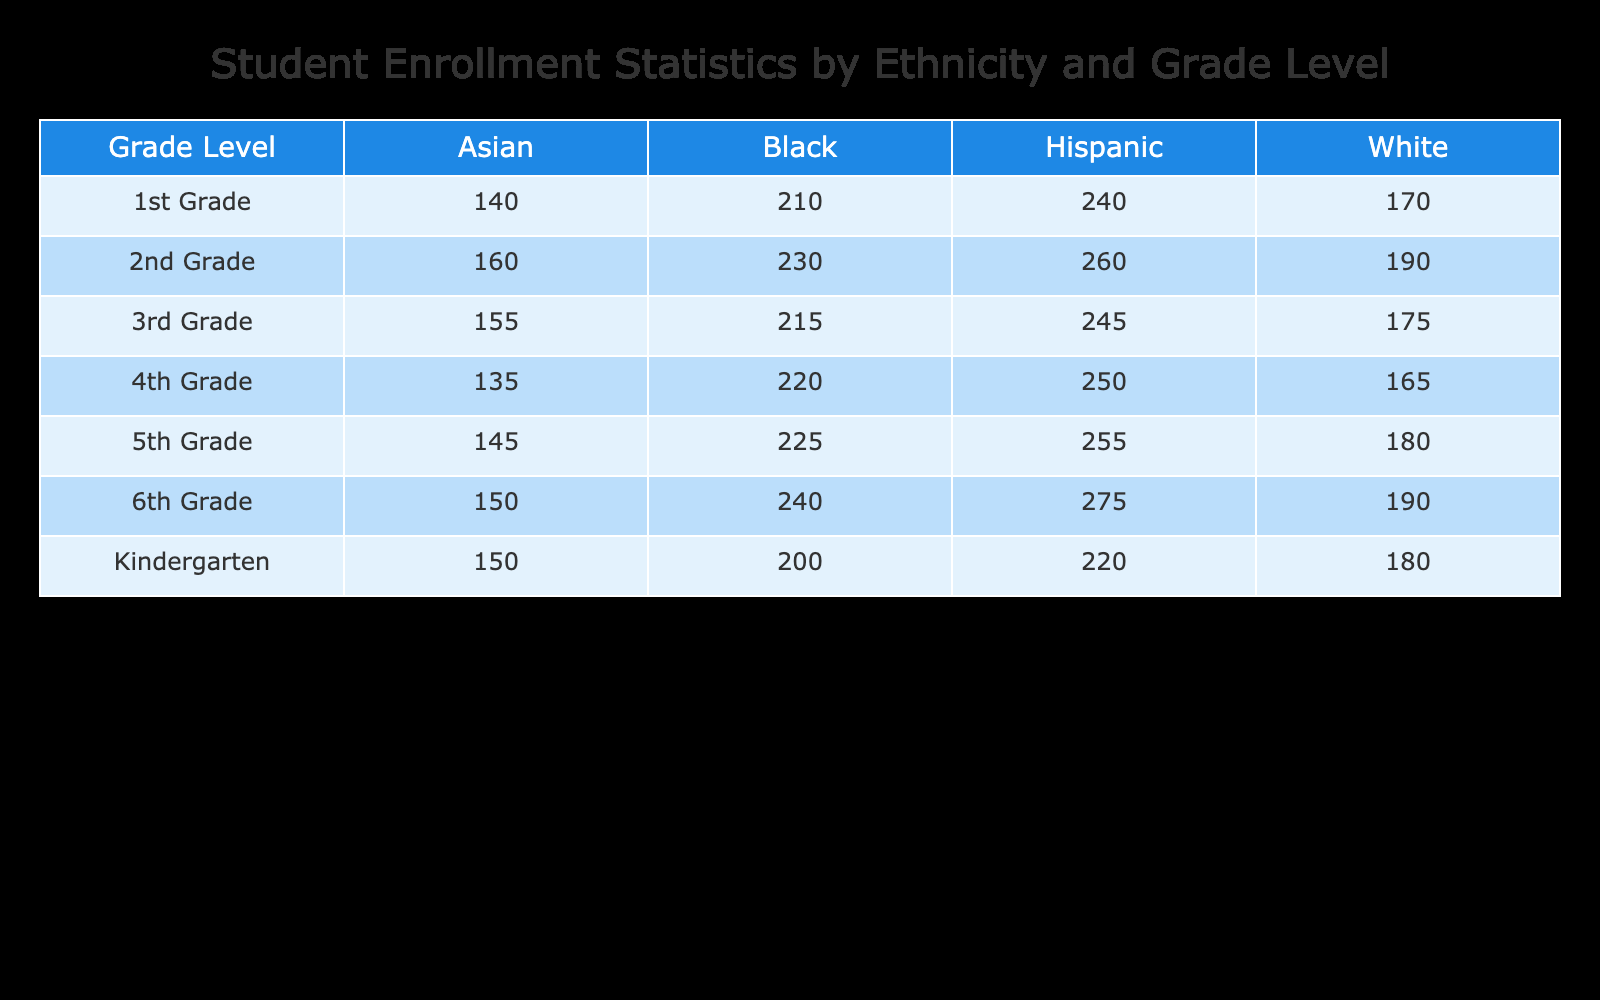What is the total enrollment for 2nd Grade? To find the total enrollment for 2nd Grade, we need to sum the numbers in the 2nd Grade row: 160 (Asian) + 230 (Black) + 260 (Hispanic) + 190 (White) = 840
Answer: 840 Which ethnicity has the highest enrollment in Kindergarten? By examining the Kindergarten row, we see the numbers are: 150 (Asian), 200 (Black), 220 (Hispanic), and 180 (White). Hispanic has the highest number at 220.
Answer: Hispanic Is the enrollment for 6th Grade higher than for Kindergarten? The total enrollment for 6th Grade is 150 + 240 + 275 + 190 = 855, while for Kindergarten it is 150 + 200 + 220 + 180 = 750. Since 855 is greater than 750, the statement is true.
Answer: Yes What is the average enrollment per ethnicity across all grade levels? First, we need to sum all the enrollment values and then divide by the number of ethnicities (4). The total enrollment across all grades is 150 + 200 + 220 + 180 + 140 + 210 + 240 + 170 + 160 + 230 + 260 + 190 + 155 + 215 + 245 + 175 + 135 + 220 + 250 + 165 + 145 + 225 + 255 + 180 + 150 + 240 + 275 + 190 = 6,235. Since there are 4 ethnicities, the average is 6235 / 4 = 1558.75.
Answer: 1558.75 How many more Black students are enrolled than Asian students in 4th Grade? In 4th Grade, the enrollment numbers are 135 (Asian) and 220 (Black). To find the difference, we subtract the Asian enrollment from the Black enrollment: 220 - 135 = 85.
Answer: 85 